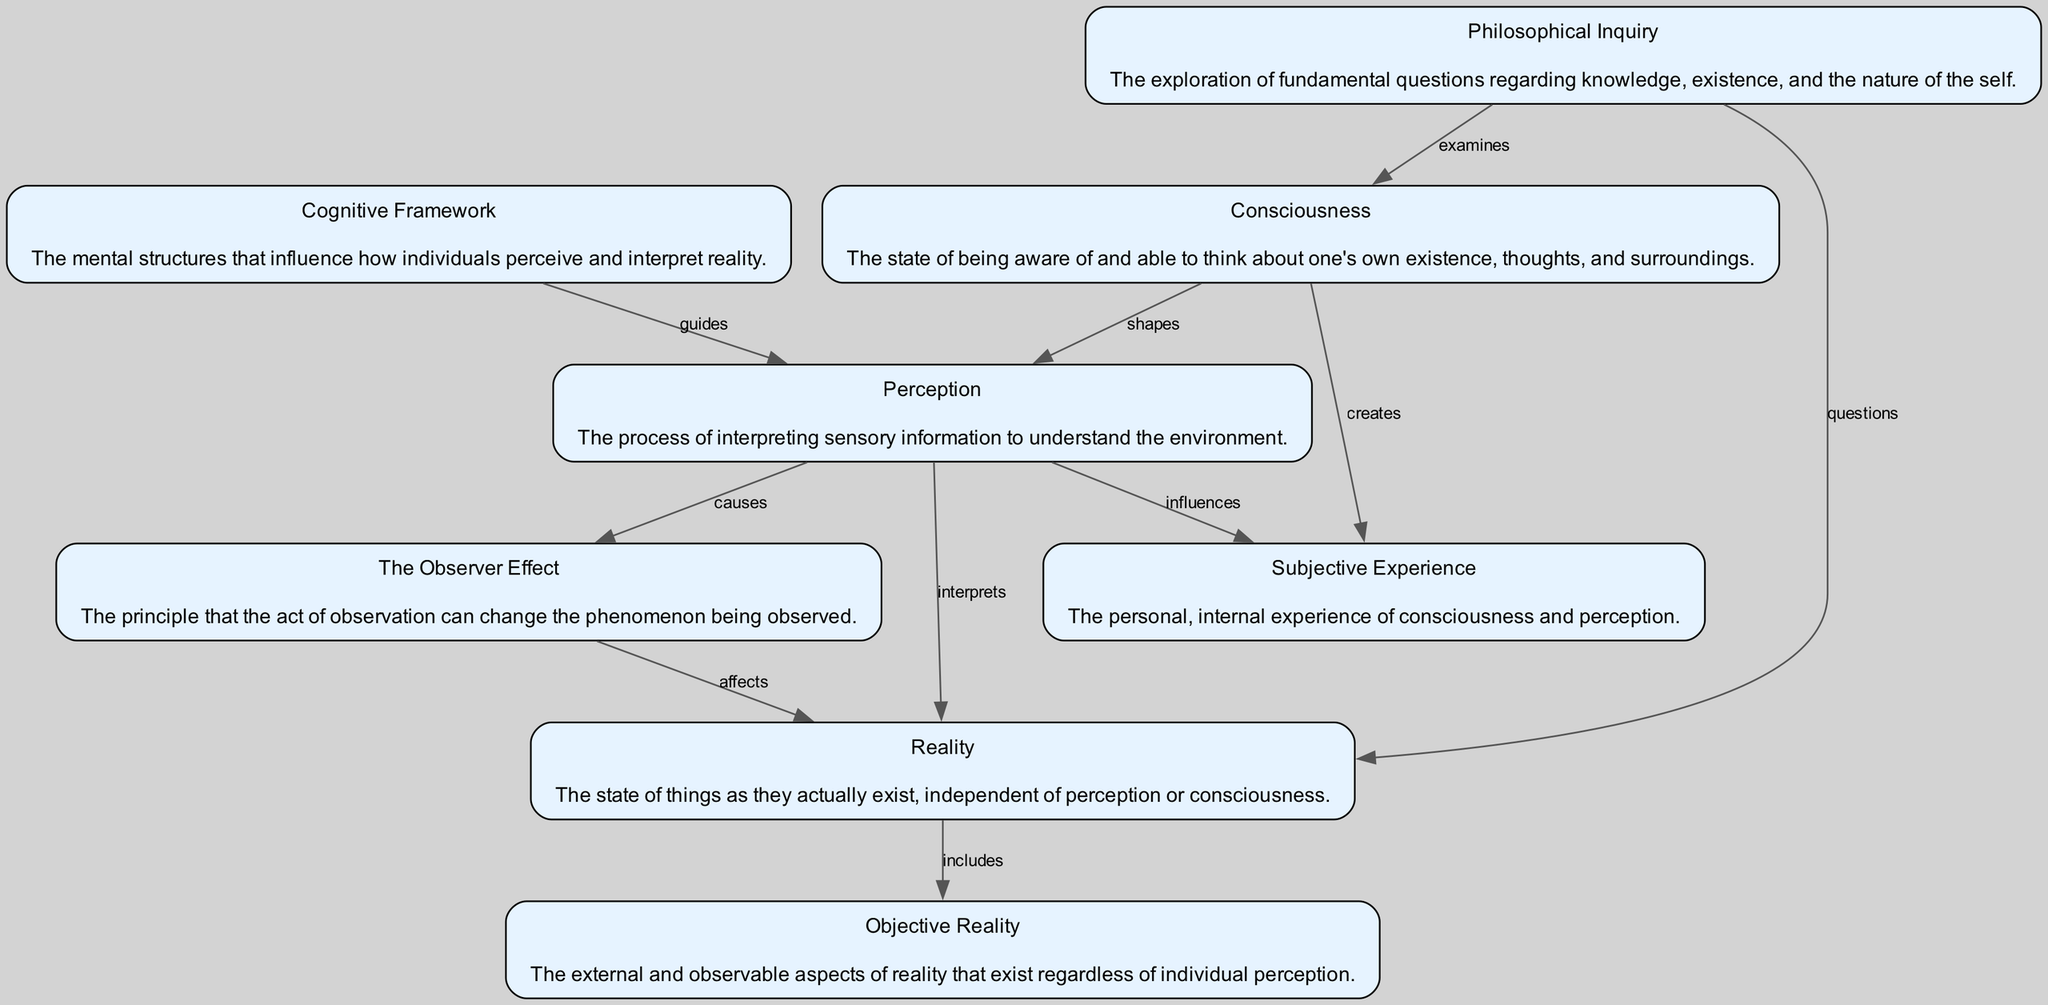What is the first node in the diagram? The first node listed in the diagram is "Consciousness". It is indicated at the top as the starting point for the flow chart.
Answer: Consciousness How many nodes are present in the diagram? Counting each unique element listed in the diagram reveals there are eight distinct nodes: Consciousness, Perception, Reality, Subjective Experience, Cognitive Framework, Objective Reality, The Observer Effect, and Philosophical Inquiry.
Answer: Eight What is the relationship between Perception and Reality? According to the diagram, Perception interprets Reality. This relationship indicates that perception plays a crucial role in understanding the actual state of things.
Answer: Interprets Which node is connected to both Consciousness and Reality through edges? The node "Philosophical Inquiry" connects to both "Consciousness" and "Reality," as indicated by its edges leading to these two nodes.
Answer: Philosophical Inquiry What causes the Observer Effect in the diagram? The diagram shows that the Observer Effect is caused by Perception, as it directly connects to this concept. When perception interacts with what is observed, the observation can change the phenomenon itself.
Answer: Perception How many edges are directed towards Reality? The flow chart shows that Reality has two directed edges pointing towards it: one from Perception (interprets) and another from Objective Reality (includes). Therefore, there are a total of two edges directed towards Reality.
Answer: Two What influences Subjective Experience according to the diagram? The diagram indicates that both Consciousness and Perception influence Subjective Experience, with arrows flowing from each of these nodes towards it, showing their interconnected nature.
Answer: Consciousness and Perception What effect does the Observer Effect have on Reality? The diagram illustrates that the Observer Effect affects Reality, indicating that observations change or influence the way reality is perceived or understood.
Answer: Affects 